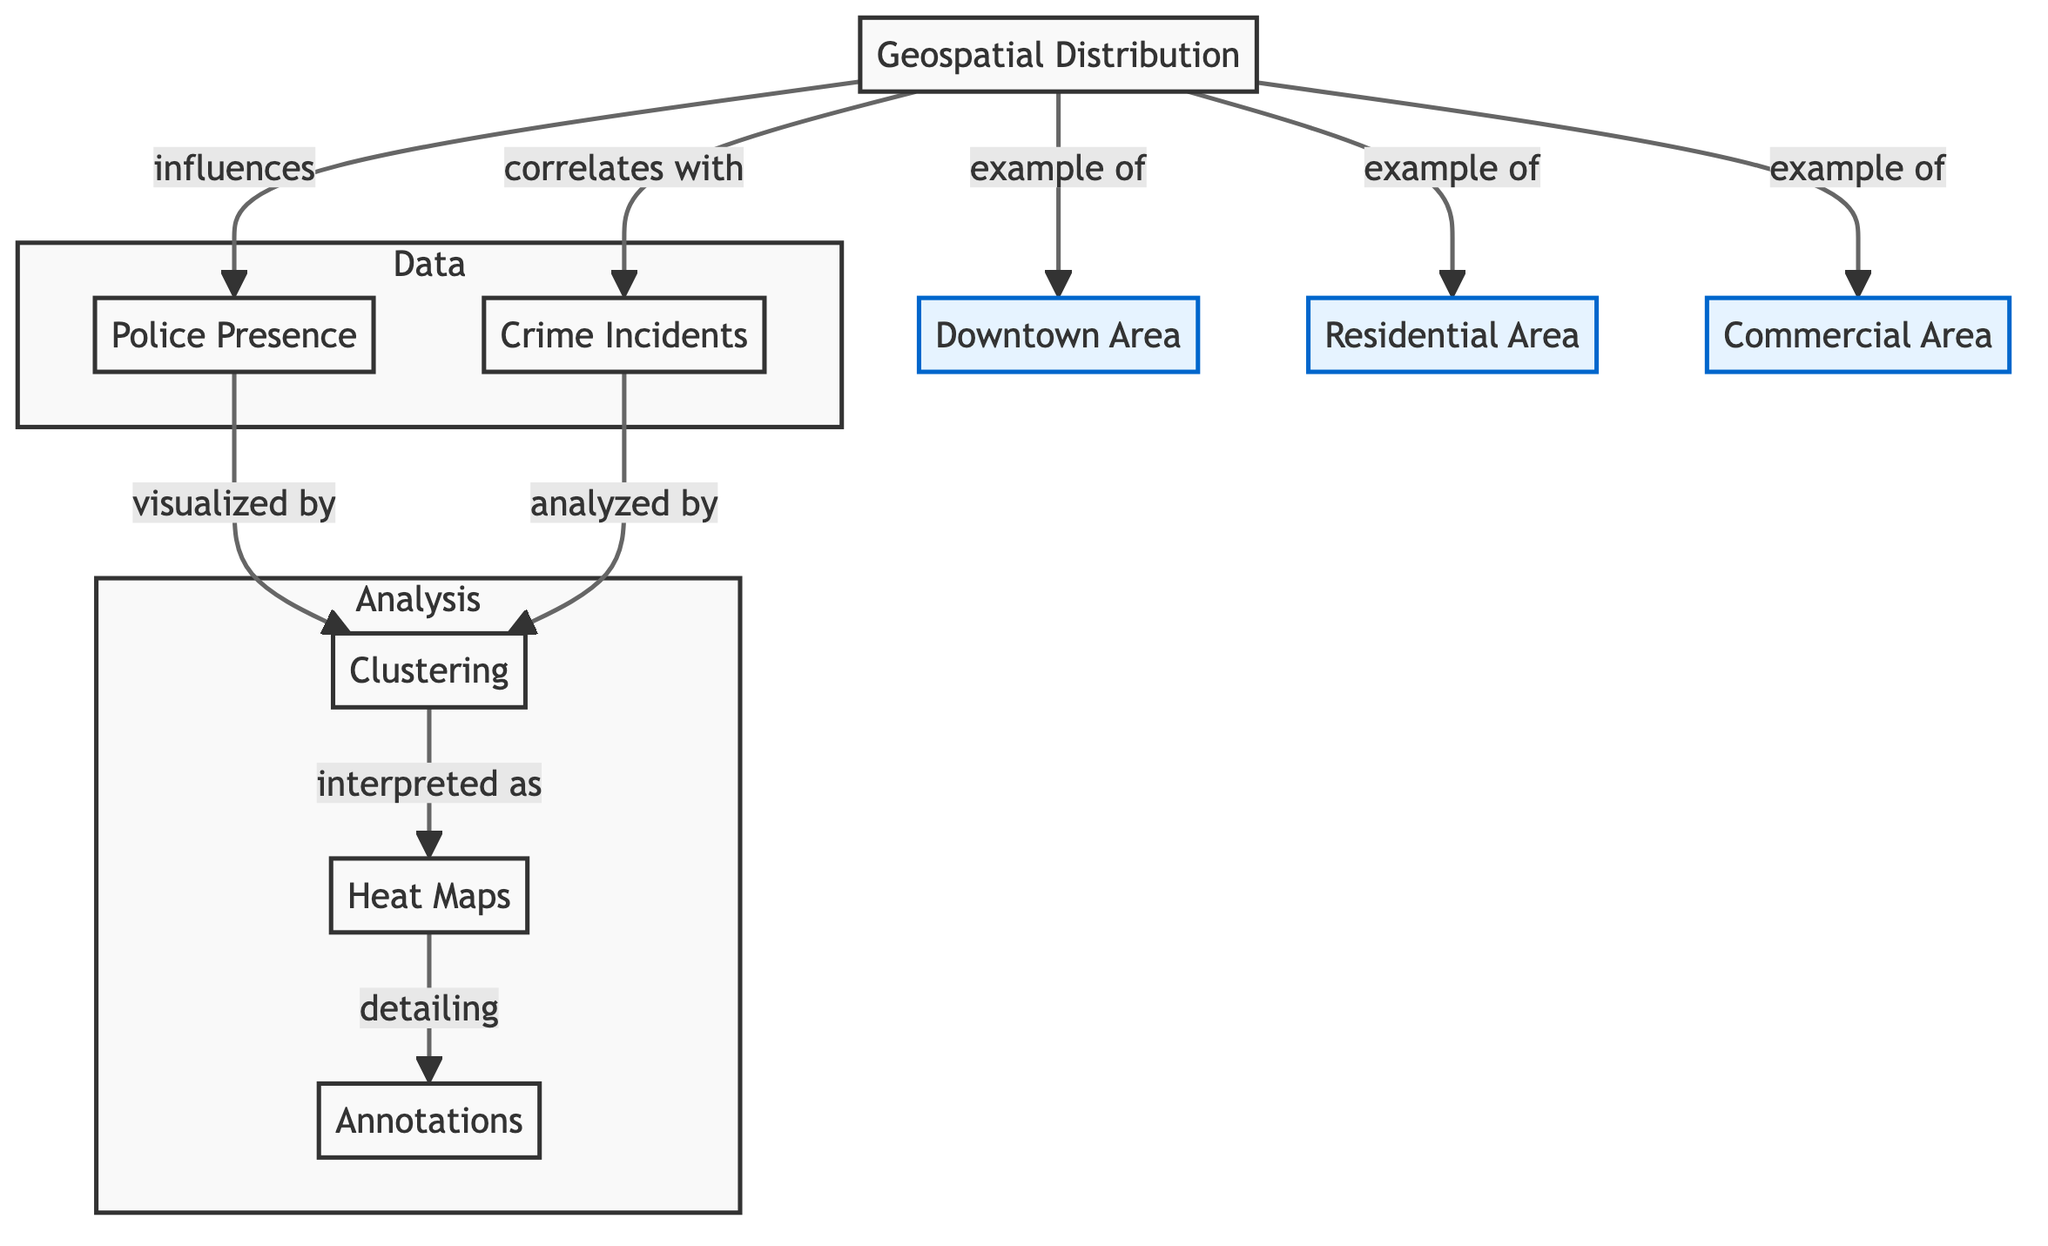What influences police presence in this diagram? The diagram indicates that geospatial distribution influences police presence, as shown by the directed arrow from geospatial distribution to police presence.
Answer: geospatial distribution What are the examples of geospatial distribution shown in the diagram? The diagram lists three examples of geospatial distribution: downtown area, residential area, and commercial area, all connected by the 'example of' relationship.
Answer: downtown area, residential area, commercial area How many types of areas are identified in the geospatial distribution? The diagram presents three distinct types of areas identified in the geospatial distribution: downtown area, residential area, and commercial area, which can be counted directly.
Answer: three What do crime incidents correlate with according to the diagram? According to the diagram, crime incidents correlate with geospatial distribution, as indicated by the arrow pointing from geospatial distribution to crime incidents.
Answer: geospatial distribution What is visualized by clustering in the context of police presence? Clustering is used to visualize police presence as indicated in the diagram where a directed edge leads from police presence to clustering.
Answer: police presence What is the relationship between crime incidents and clustering? The diagram shows that clustering analyzes crime incidents, demonstrated by the arrow from crime incidents to clustering, indicating a direct relationship.
Answer: analyzes How is heat map related to annotations in the diagram? The relationship is shown in the diagram where heat maps detail annotations, indicated by the directed edge from heat maps to annotations.
Answer: detail Which subgraph contains clustering and heat maps? The subgraph labeled 'Analysis' contains both clustering and heat maps, as depicted by the organization of the nodes in that section.
Answer: Analysis What type of analysis is performed on geospatial distribution? The analysis performed involves clustering and visualization, as it connects to both heat maps and annotations in the Analysis subgraph.
Answer: clustering and visualization 